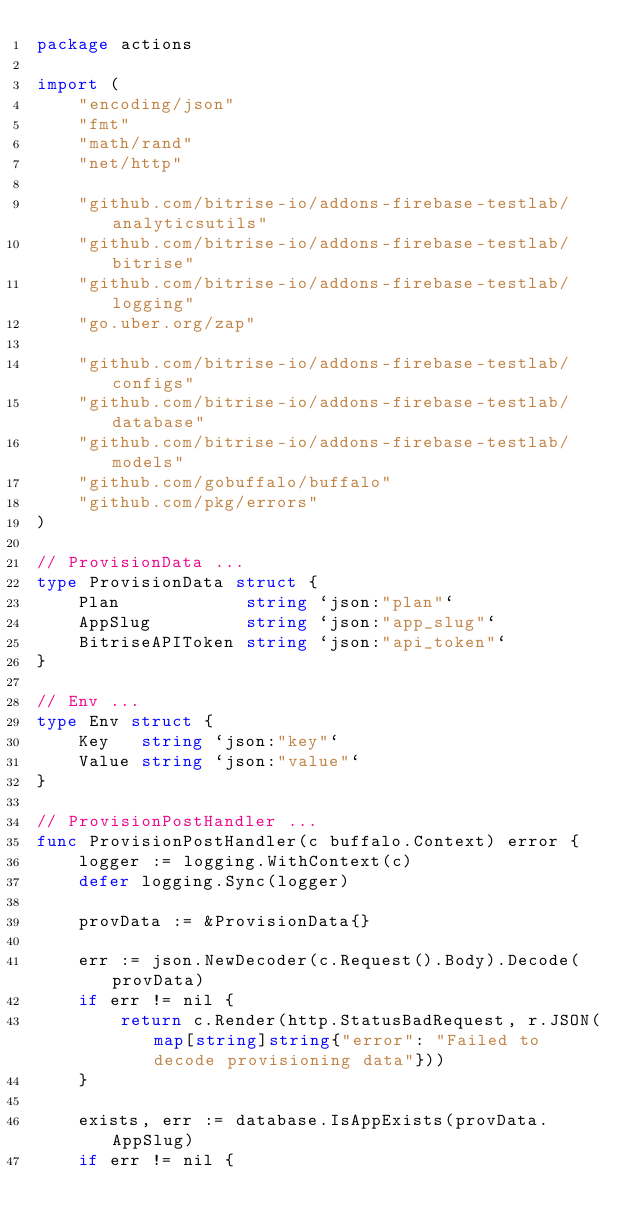Convert code to text. <code><loc_0><loc_0><loc_500><loc_500><_Go_>package actions

import (
	"encoding/json"
	"fmt"
	"math/rand"
	"net/http"

	"github.com/bitrise-io/addons-firebase-testlab/analyticsutils"
	"github.com/bitrise-io/addons-firebase-testlab/bitrise"
	"github.com/bitrise-io/addons-firebase-testlab/logging"
	"go.uber.org/zap"

	"github.com/bitrise-io/addons-firebase-testlab/configs"
	"github.com/bitrise-io/addons-firebase-testlab/database"
	"github.com/bitrise-io/addons-firebase-testlab/models"
	"github.com/gobuffalo/buffalo"
	"github.com/pkg/errors"
)

// ProvisionData ...
type ProvisionData struct {
	Plan            string `json:"plan"`
	AppSlug         string `json:"app_slug"`
	BitriseAPIToken string `json:"api_token"`
}

// Env ...
type Env struct {
	Key   string `json:"key"`
	Value string `json:"value"`
}

// ProvisionPostHandler ...
func ProvisionPostHandler(c buffalo.Context) error {
	logger := logging.WithContext(c)
	defer logging.Sync(logger)

	provData := &ProvisionData{}

	err := json.NewDecoder(c.Request().Body).Decode(provData)
	if err != nil {
		return c.Render(http.StatusBadRequest, r.JSON(map[string]string{"error": "Failed to decode provisioning data"}))
	}

	exists, err := database.IsAppExists(provData.AppSlug)
	if err != nil {</code> 